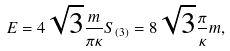Convert formula to latex. <formula><loc_0><loc_0><loc_500><loc_500>E = 4 \sqrt { 3 } \frac { m } { \pi \kappa } S _ { ( 3 ) } = 8 \sqrt { 3 } \frac { \pi } { \kappa } m ,</formula> 